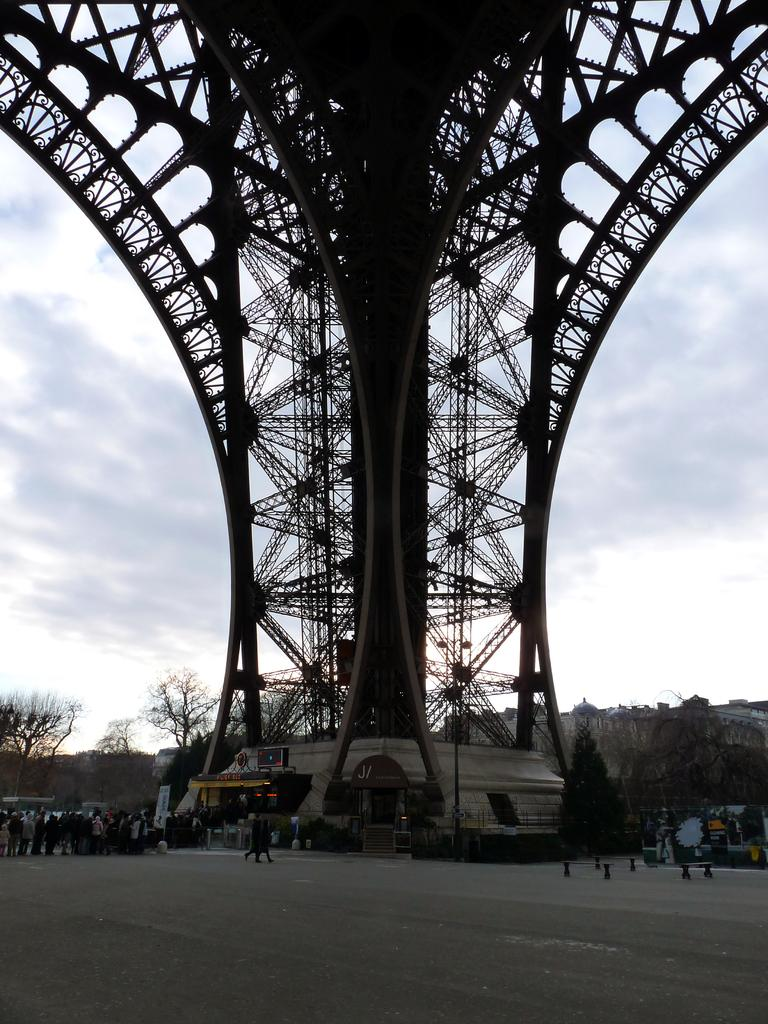What is the main structure in the image? There is a tower in the image. What can be seen in the background of the image? There are trees and people in the background of the image. What is at the bottom of the image? There is a road at the bottom of the image. What type of error can be seen in the image? There is no error present in the image; it is a clear depiction of a tower, trees, people, and a road. How many cars are visible in the image? There are no cars visible in the image. 